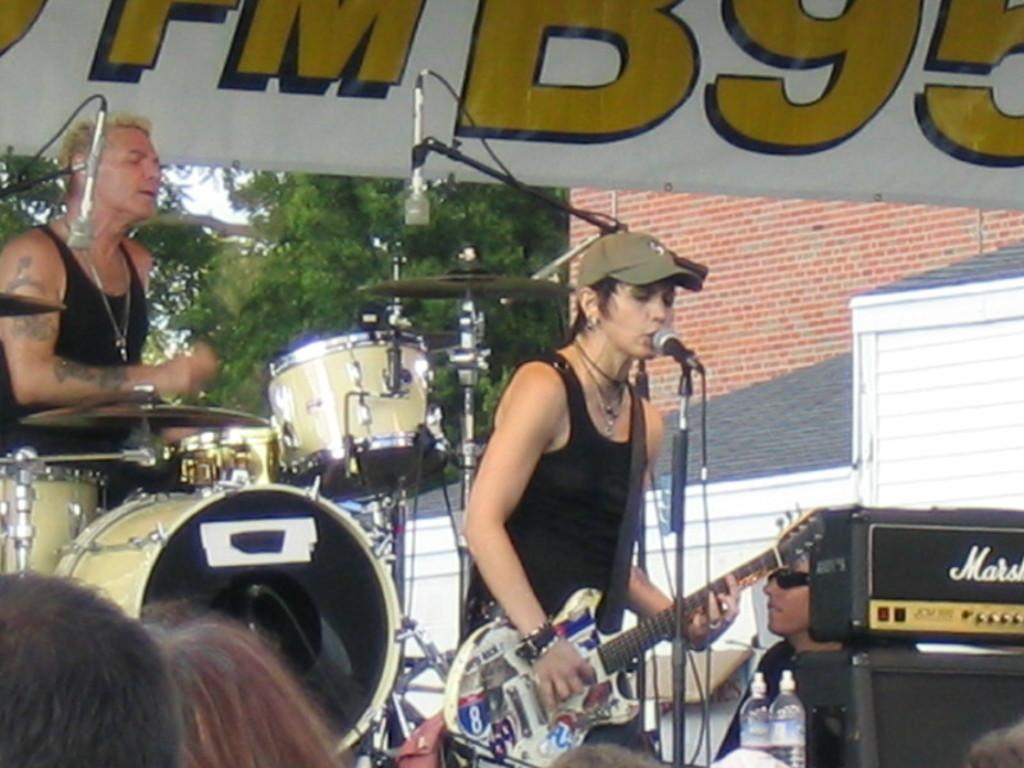What activity is the person in the image engaged in? The person is playing a piano. What instrument is the person playing? The person is playing a piano. Can you describe the setting where the person is playing the piano? The setting is not specified in the facts provided. What type of cord is connected to the piano in the image? There is no mention of a cord connected to the piano in the image. What does the piano taste like in the image? Pianos are not edible and therefore cannot be tasted. 